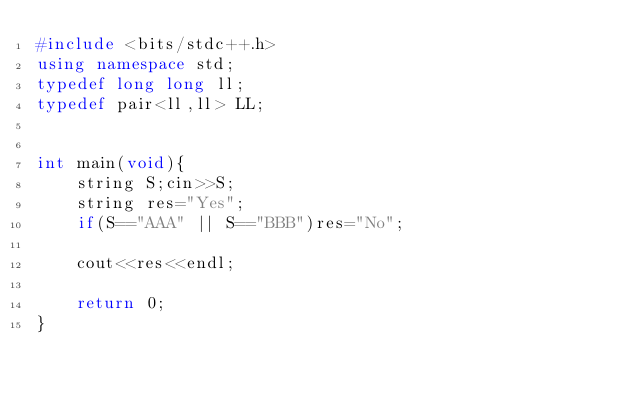Convert code to text. <code><loc_0><loc_0><loc_500><loc_500><_C++_>#include <bits/stdc++.h>
using namespace std;
typedef long long ll;
typedef pair<ll,ll> LL;


int main(void){
    string S;cin>>S;
    string res="Yes";
    if(S=="AAA" || S=="BBB")res="No";

    cout<<res<<endl;

    return 0;
}</code> 